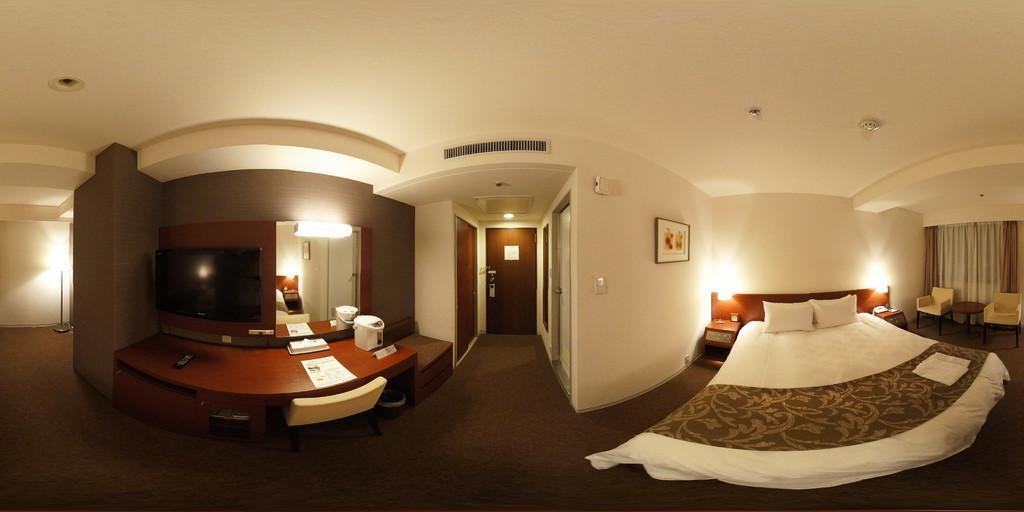Can you describe this image briefly? In this image we can see an inside view of a room. To the right side of the image we can see two pillows placed on the bed placed on the ground, two chairs and a table placed on the ground and the curtain. In the center of the image we can see three doors and a photo frame on the wall. To the left side of the image we can see a television on a wall, mirror, light placed on the ground. In the background we can see some lights. 